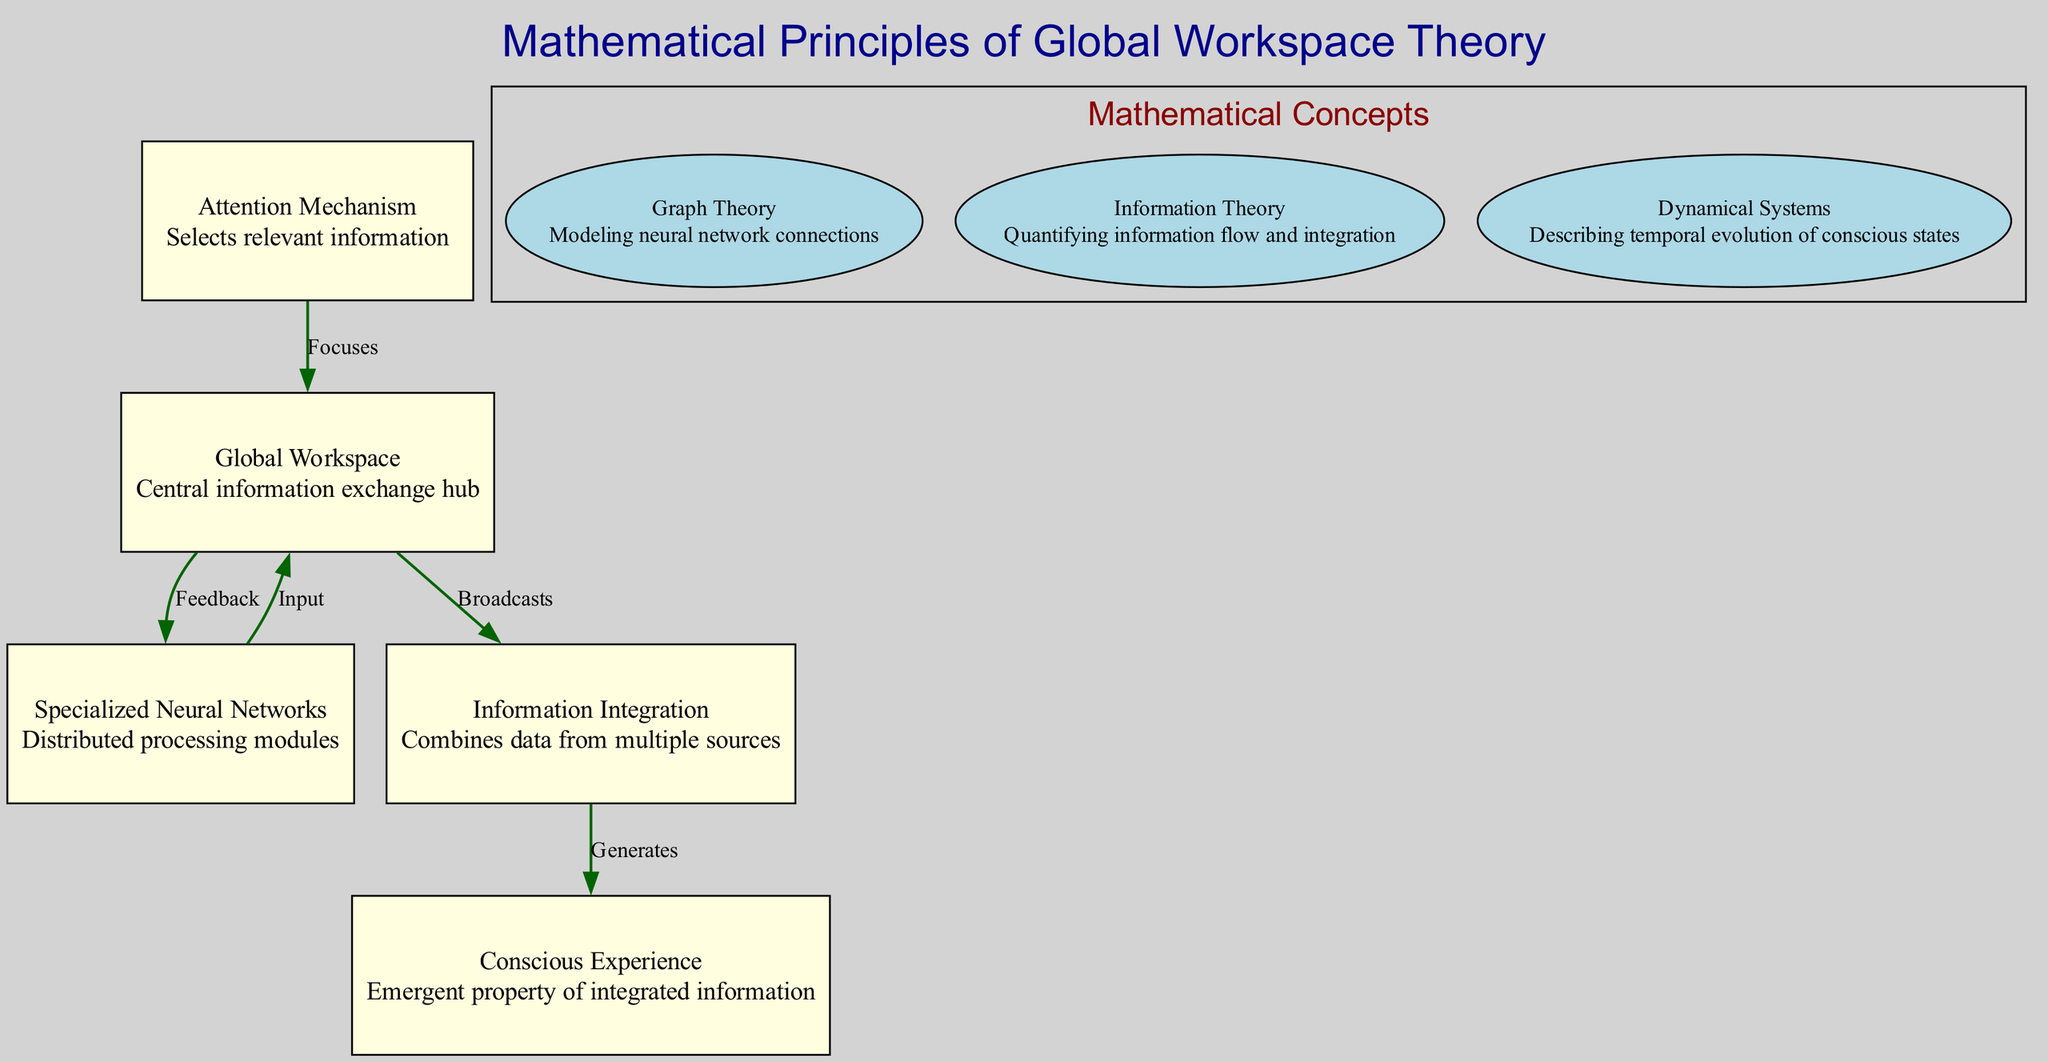What is the main function of the Global Workspace? The Global Workspace serves as the central hub for information exchange among different nodes in the system, facilitating communication and coordination within consciousness.
Answer: Central information exchange hub How many specialized neural networks are present in the diagram? There is only one node labeled "Specialized Neural Networks" reflecting the primary component of distributed processing, hence the count is one.
Answer: 1 What role does the Attention Mechanism play in information processing? The Attention Mechanism focuses on selecting relevant information before it is processed by the Global Workspace, influencing what gets attended to in consciousness.
Answer: Selects relevant information Which node directly generates Conscious Experience? The node that directly contributes to the generation of Conscious Experience is the Information Integration node, as it combines data from various sources to create this emergent property.
Answer: Information Integration What type of mathematical concept is used for modeling neural network connections? The diagram indicates that Graph Theory is the mathematical concept utilized specifically for modeling the connections within neural networks present in this framework.
Answer: Graph Theory How does information flow from the Global Workspace to Conscious Experience? Information flows from the Global Workspace to Conscious Experience through the Information Integration node, which acts as an intermediary to generate conscious awareness from integrated information.
Answer: Broadcasts What relationship is depicted between Specialized Neural Networks and the Global Workspace? The relationship indicated is one of input, where the Specialized Neural Networks send information to the Global Workspace, emphasizing a flow of data being managed.
Answer: Input How many edges are shown in the diagram? The diagram has a total of five edges representing the different relationships and flows between the nodes, indicating the interactions that define the Global Workspace Theory structure.
Answer: 5 